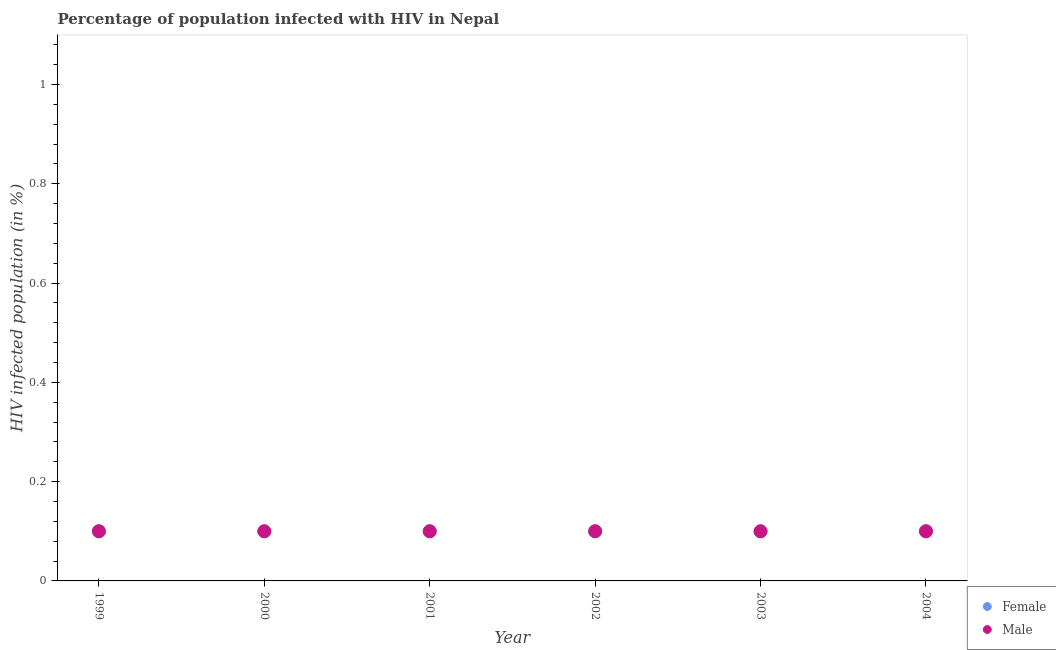How many different coloured dotlines are there?
Your answer should be compact. 2. Across all years, what is the maximum percentage of males who are infected with hiv?
Ensure brevity in your answer.  0.1. Across all years, what is the minimum percentage of females who are infected with hiv?
Your answer should be very brief. 0.1. What is the total percentage of males who are infected with hiv in the graph?
Your answer should be very brief. 0.6. What is the average percentage of females who are infected with hiv per year?
Provide a short and direct response. 0.1. What is the ratio of the percentage of females who are infected with hiv in 2000 to that in 2002?
Ensure brevity in your answer.  1. What is the difference between the highest and the lowest percentage of females who are infected with hiv?
Keep it short and to the point. 0. Does the percentage of males who are infected with hiv monotonically increase over the years?
Offer a very short reply. No. Is the percentage of females who are infected with hiv strictly greater than the percentage of males who are infected with hiv over the years?
Keep it short and to the point. No. How many dotlines are there?
Keep it short and to the point. 2. What is the difference between two consecutive major ticks on the Y-axis?
Your answer should be compact. 0.2. Does the graph contain any zero values?
Ensure brevity in your answer.  No. Does the graph contain grids?
Offer a terse response. No. How many legend labels are there?
Your response must be concise. 2. What is the title of the graph?
Provide a short and direct response. Percentage of population infected with HIV in Nepal. Does "Health Care" appear as one of the legend labels in the graph?
Provide a short and direct response. No. What is the label or title of the Y-axis?
Your answer should be very brief. HIV infected population (in %). What is the HIV infected population (in %) in Male in 1999?
Offer a terse response. 0.1. What is the HIV infected population (in %) of Male in 2000?
Offer a very short reply. 0.1. What is the HIV infected population (in %) of Male in 2002?
Provide a succinct answer. 0.1. What is the HIV infected population (in %) of Female in 2004?
Your answer should be compact. 0.1. Across all years, what is the minimum HIV infected population (in %) in Female?
Your answer should be very brief. 0.1. What is the difference between the HIV infected population (in %) of Female in 1999 and that in 2000?
Provide a short and direct response. 0. What is the difference between the HIV infected population (in %) in Female in 1999 and that in 2001?
Give a very brief answer. 0. What is the difference between the HIV infected population (in %) in Female in 1999 and that in 2002?
Your answer should be very brief. 0. What is the difference between the HIV infected population (in %) in Male in 1999 and that in 2002?
Make the answer very short. 0. What is the difference between the HIV infected population (in %) of Male in 1999 and that in 2003?
Make the answer very short. 0. What is the difference between the HIV infected population (in %) in Male in 1999 and that in 2004?
Offer a terse response. 0. What is the difference between the HIV infected population (in %) of Male in 2000 and that in 2001?
Ensure brevity in your answer.  0. What is the difference between the HIV infected population (in %) in Female in 2000 and that in 2002?
Provide a short and direct response. 0. What is the difference between the HIV infected population (in %) in Male in 2000 and that in 2002?
Provide a short and direct response. 0. What is the difference between the HIV infected population (in %) of Female in 2000 and that in 2003?
Give a very brief answer. 0. What is the difference between the HIV infected population (in %) of Female in 2000 and that in 2004?
Your answer should be very brief. 0. What is the difference between the HIV infected population (in %) in Female in 2001 and that in 2002?
Ensure brevity in your answer.  0. What is the difference between the HIV infected population (in %) of Female in 2001 and that in 2003?
Your answer should be compact. 0. What is the difference between the HIV infected population (in %) of Female in 2001 and that in 2004?
Provide a succinct answer. 0. What is the difference between the HIV infected population (in %) in Female in 2002 and that in 2003?
Ensure brevity in your answer.  0. What is the difference between the HIV infected population (in %) in Male in 2002 and that in 2003?
Offer a very short reply. 0. What is the difference between the HIV infected population (in %) of Male in 2002 and that in 2004?
Offer a terse response. 0. What is the difference between the HIV infected population (in %) in Female in 2003 and that in 2004?
Make the answer very short. 0. What is the difference between the HIV infected population (in %) in Male in 2003 and that in 2004?
Offer a very short reply. 0. What is the difference between the HIV infected population (in %) in Female in 1999 and the HIV infected population (in %) in Male in 2004?
Make the answer very short. 0. What is the difference between the HIV infected population (in %) in Female in 2000 and the HIV infected population (in %) in Male in 2001?
Your answer should be compact. 0. What is the difference between the HIV infected population (in %) of Female in 2000 and the HIV infected population (in %) of Male in 2003?
Offer a terse response. 0. What is the difference between the HIV infected population (in %) of Female in 2001 and the HIV infected population (in %) of Male in 2003?
Keep it short and to the point. 0. What is the difference between the HIV infected population (in %) in Female in 2001 and the HIV infected population (in %) in Male in 2004?
Provide a short and direct response. 0. What is the difference between the HIV infected population (in %) of Female in 2002 and the HIV infected population (in %) of Male in 2003?
Give a very brief answer. 0. In the year 1999, what is the difference between the HIV infected population (in %) of Female and HIV infected population (in %) of Male?
Offer a very short reply. 0. In the year 2000, what is the difference between the HIV infected population (in %) in Female and HIV infected population (in %) in Male?
Give a very brief answer. 0. In the year 2002, what is the difference between the HIV infected population (in %) in Female and HIV infected population (in %) in Male?
Keep it short and to the point. 0. What is the ratio of the HIV infected population (in %) in Male in 1999 to that in 2000?
Your answer should be compact. 1. What is the ratio of the HIV infected population (in %) in Female in 1999 to that in 2002?
Offer a terse response. 1. What is the ratio of the HIV infected population (in %) in Male in 1999 to that in 2002?
Make the answer very short. 1. What is the ratio of the HIV infected population (in %) in Male in 1999 to that in 2004?
Your response must be concise. 1. What is the ratio of the HIV infected population (in %) of Female in 2000 to that in 2001?
Ensure brevity in your answer.  1. What is the ratio of the HIV infected population (in %) in Male in 2000 to that in 2001?
Provide a short and direct response. 1. What is the ratio of the HIV infected population (in %) in Female in 2000 to that in 2002?
Your answer should be compact. 1. What is the ratio of the HIV infected population (in %) in Female in 2000 to that in 2004?
Offer a terse response. 1. What is the ratio of the HIV infected population (in %) of Male in 2000 to that in 2004?
Your answer should be very brief. 1. What is the ratio of the HIV infected population (in %) of Female in 2001 to that in 2002?
Give a very brief answer. 1. What is the ratio of the HIV infected population (in %) of Male in 2001 to that in 2002?
Give a very brief answer. 1. What is the ratio of the HIV infected population (in %) in Female in 2001 to that in 2003?
Make the answer very short. 1. What is the ratio of the HIV infected population (in %) of Male in 2001 to that in 2003?
Your answer should be compact. 1. What is the ratio of the HIV infected population (in %) in Male in 2001 to that in 2004?
Make the answer very short. 1. What is the ratio of the HIV infected population (in %) of Female in 2002 to that in 2004?
Provide a short and direct response. 1. What is the ratio of the HIV infected population (in %) of Male in 2002 to that in 2004?
Keep it short and to the point. 1. What is the ratio of the HIV infected population (in %) in Female in 2003 to that in 2004?
Offer a very short reply. 1. What is the difference between the highest and the second highest HIV infected population (in %) of Male?
Offer a very short reply. 0. What is the difference between the highest and the lowest HIV infected population (in %) of Female?
Give a very brief answer. 0. 